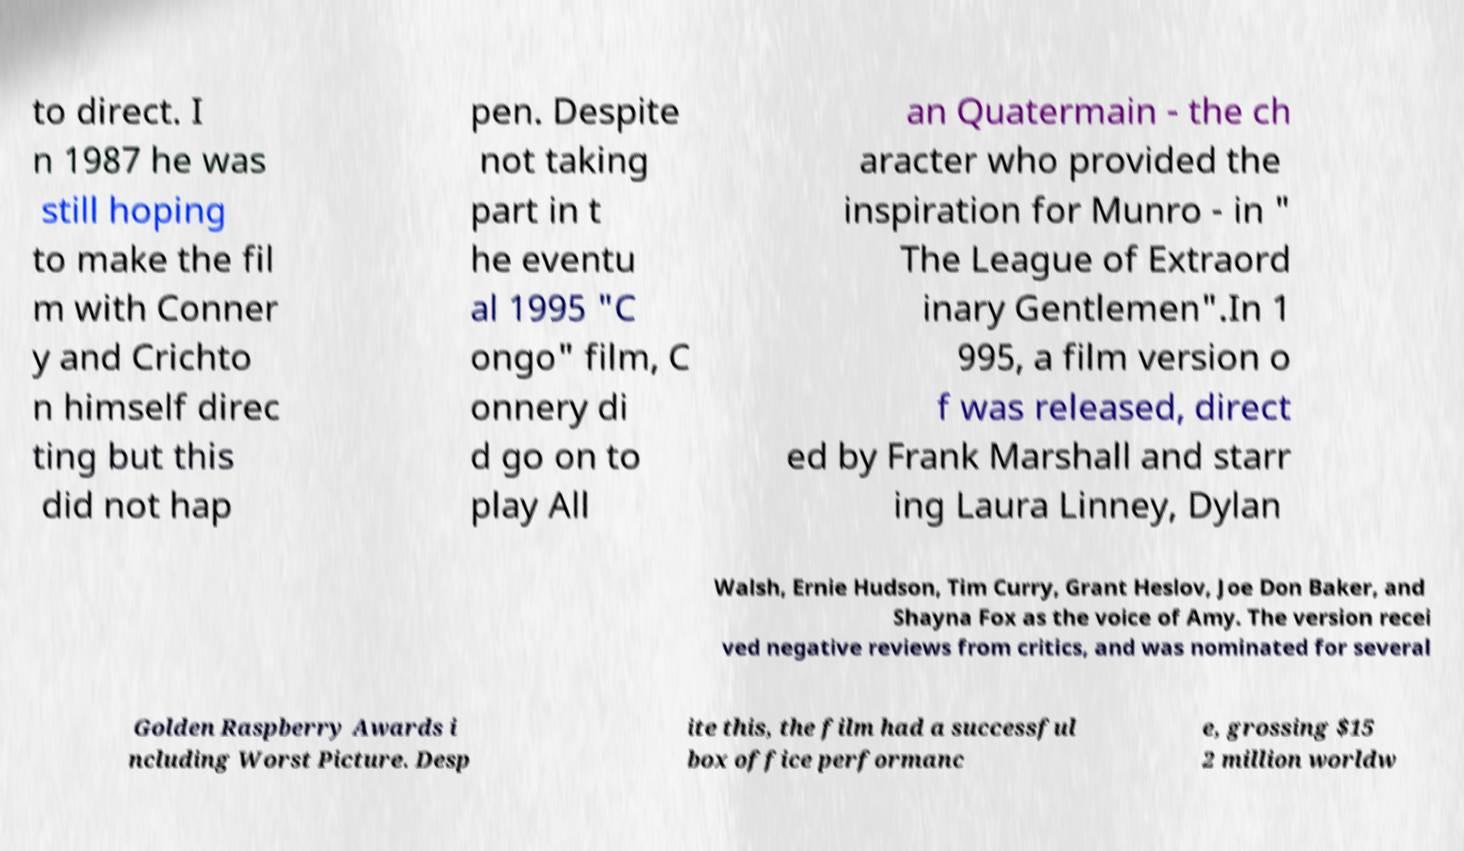For documentation purposes, I need the text within this image transcribed. Could you provide that? to direct. I n 1987 he was still hoping to make the fil m with Conner y and Crichto n himself direc ting but this did not hap pen. Despite not taking part in t he eventu al 1995 "C ongo" film, C onnery di d go on to play All an Quatermain - the ch aracter who provided the inspiration for Munro - in " The League of Extraord inary Gentlemen".In 1 995, a film version o f was released, direct ed by Frank Marshall and starr ing Laura Linney, Dylan Walsh, Ernie Hudson, Tim Curry, Grant Heslov, Joe Don Baker, and Shayna Fox as the voice of Amy. The version recei ved negative reviews from critics, and was nominated for several Golden Raspberry Awards i ncluding Worst Picture. Desp ite this, the film had a successful box office performanc e, grossing $15 2 million worldw 